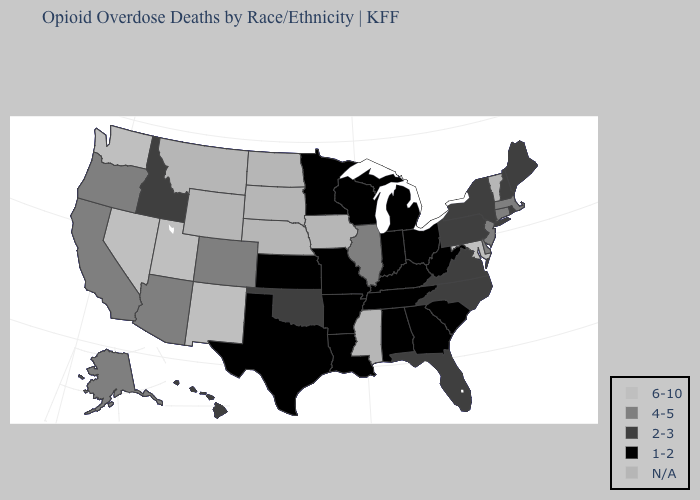What is the value of Hawaii?
Keep it brief. 2-3. Among the states that border Louisiana , which have the highest value?
Keep it brief. Arkansas, Texas. Which states hav the highest value in the South?
Give a very brief answer. Maryland. Does the first symbol in the legend represent the smallest category?
Concise answer only. No. Does Rhode Island have the lowest value in the USA?
Concise answer only. No. What is the lowest value in the USA?
Short answer required. 1-2. How many symbols are there in the legend?
Concise answer only. 5. What is the lowest value in the West?
Be succinct. 2-3. Name the states that have a value in the range 4-5?
Keep it brief. Alaska, Arizona, California, Colorado, Connecticut, Delaware, Illinois, Massachusetts, New Jersey, Oregon. Name the states that have a value in the range 4-5?
Give a very brief answer. Alaska, Arizona, California, Colorado, Connecticut, Delaware, Illinois, Massachusetts, New Jersey, Oregon. What is the value of Utah?
Be succinct. 6-10. What is the value of Georgia?
Quick response, please. 1-2. Is the legend a continuous bar?
Be succinct. No. Name the states that have a value in the range 4-5?
Give a very brief answer. Alaska, Arizona, California, Colorado, Connecticut, Delaware, Illinois, Massachusetts, New Jersey, Oregon. 